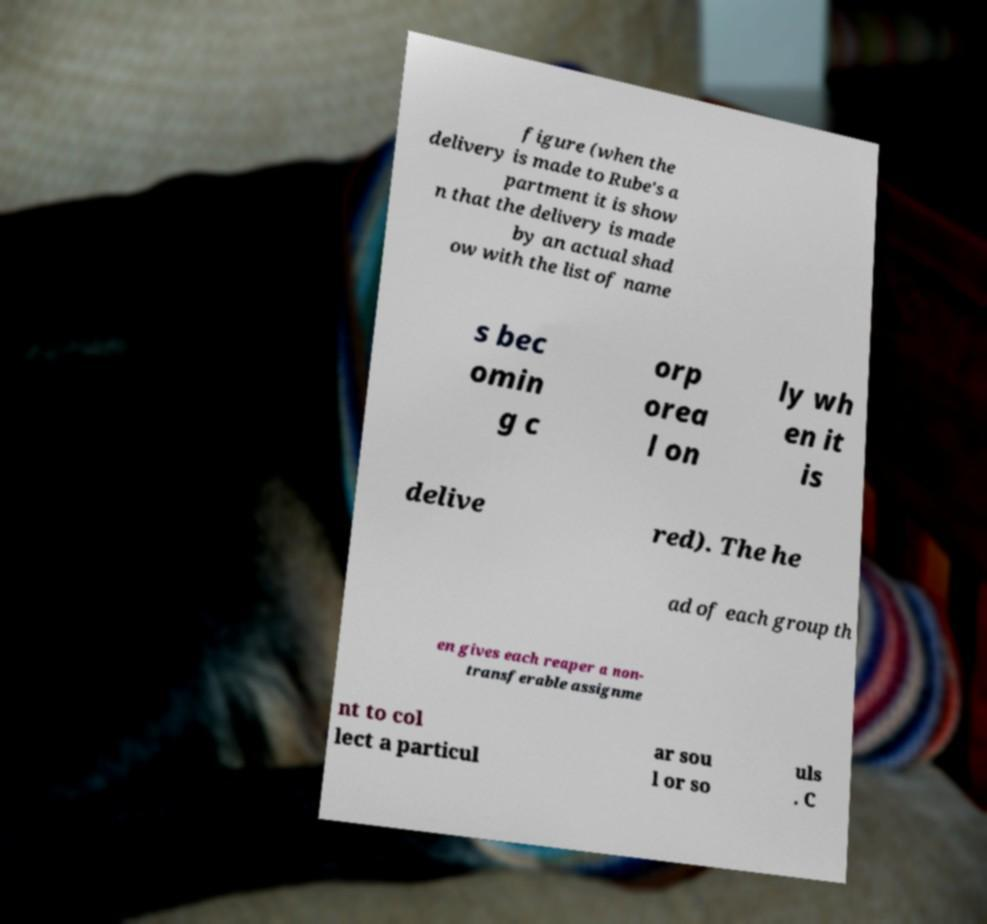What messages or text are displayed in this image? I need them in a readable, typed format. figure (when the delivery is made to Rube's a partment it is show n that the delivery is made by an actual shad ow with the list of name s bec omin g c orp orea l on ly wh en it is delive red). The he ad of each group th en gives each reaper a non- transferable assignme nt to col lect a particul ar sou l or so uls . C 